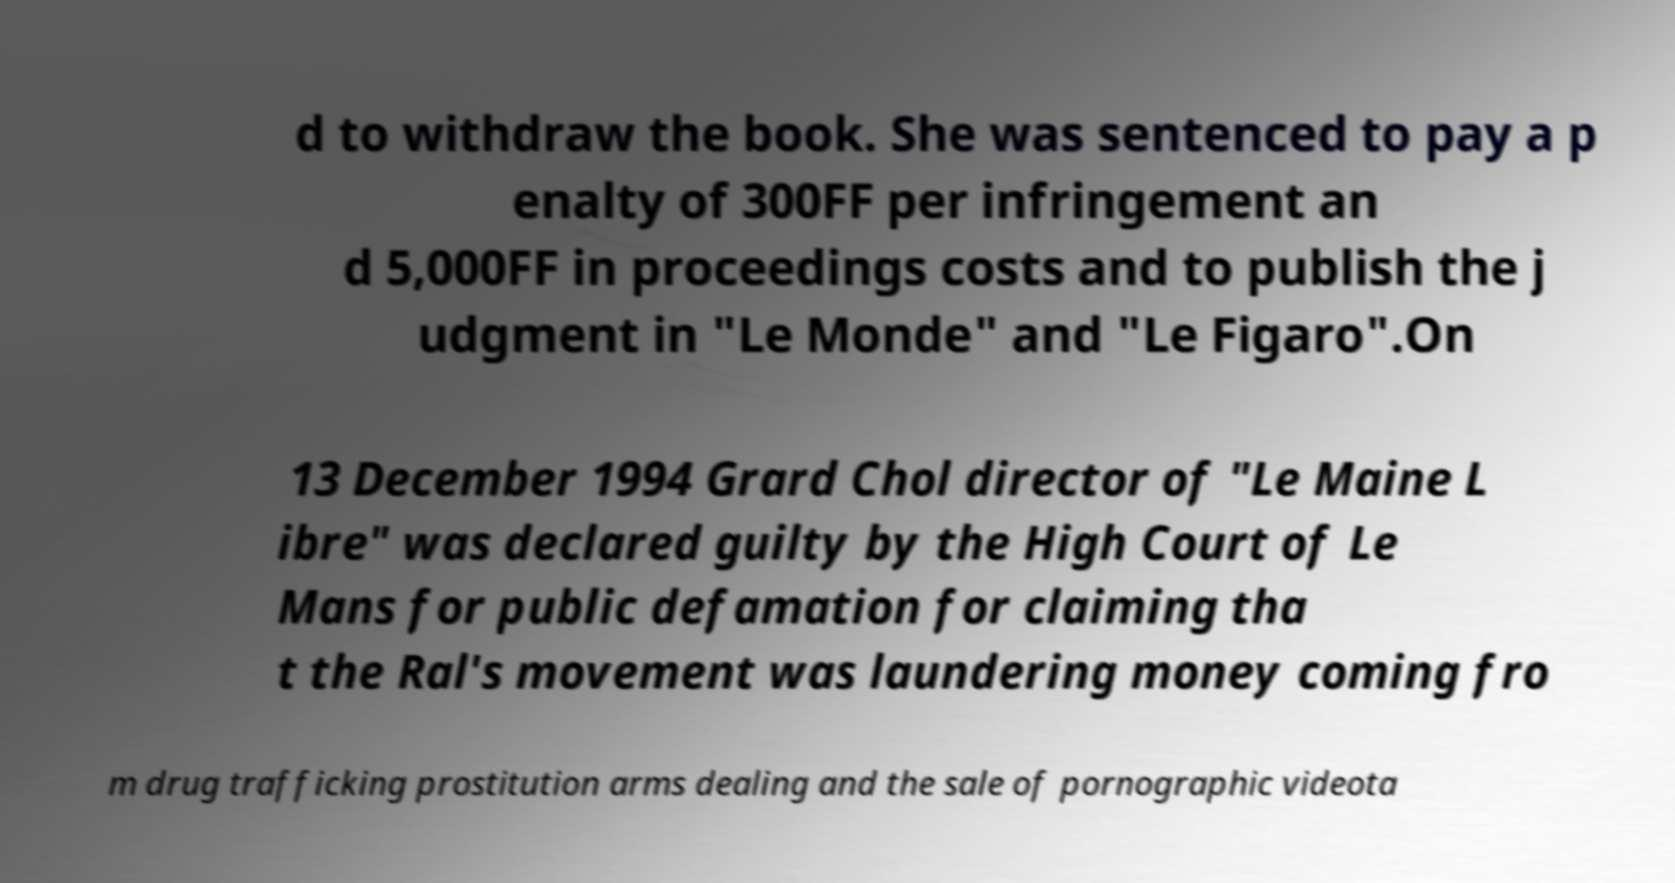Could you assist in decoding the text presented in this image and type it out clearly? d to withdraw the book. She was sentenced to pay a p enalty of 300FF per infringement an d 5,000FF in proceedings costs and to publish the j udgment in "Le Monde" and "Le Figaro".On 13 December 1994 Grard Chol director of "Le Maine L ibre" was declared guilty by the High Court of Le Mans for public defamation for claiming tha t the Ral's movement was laundering money coming fro m drug trafficking prostitution arms dealing and the sale of pornographic videota 